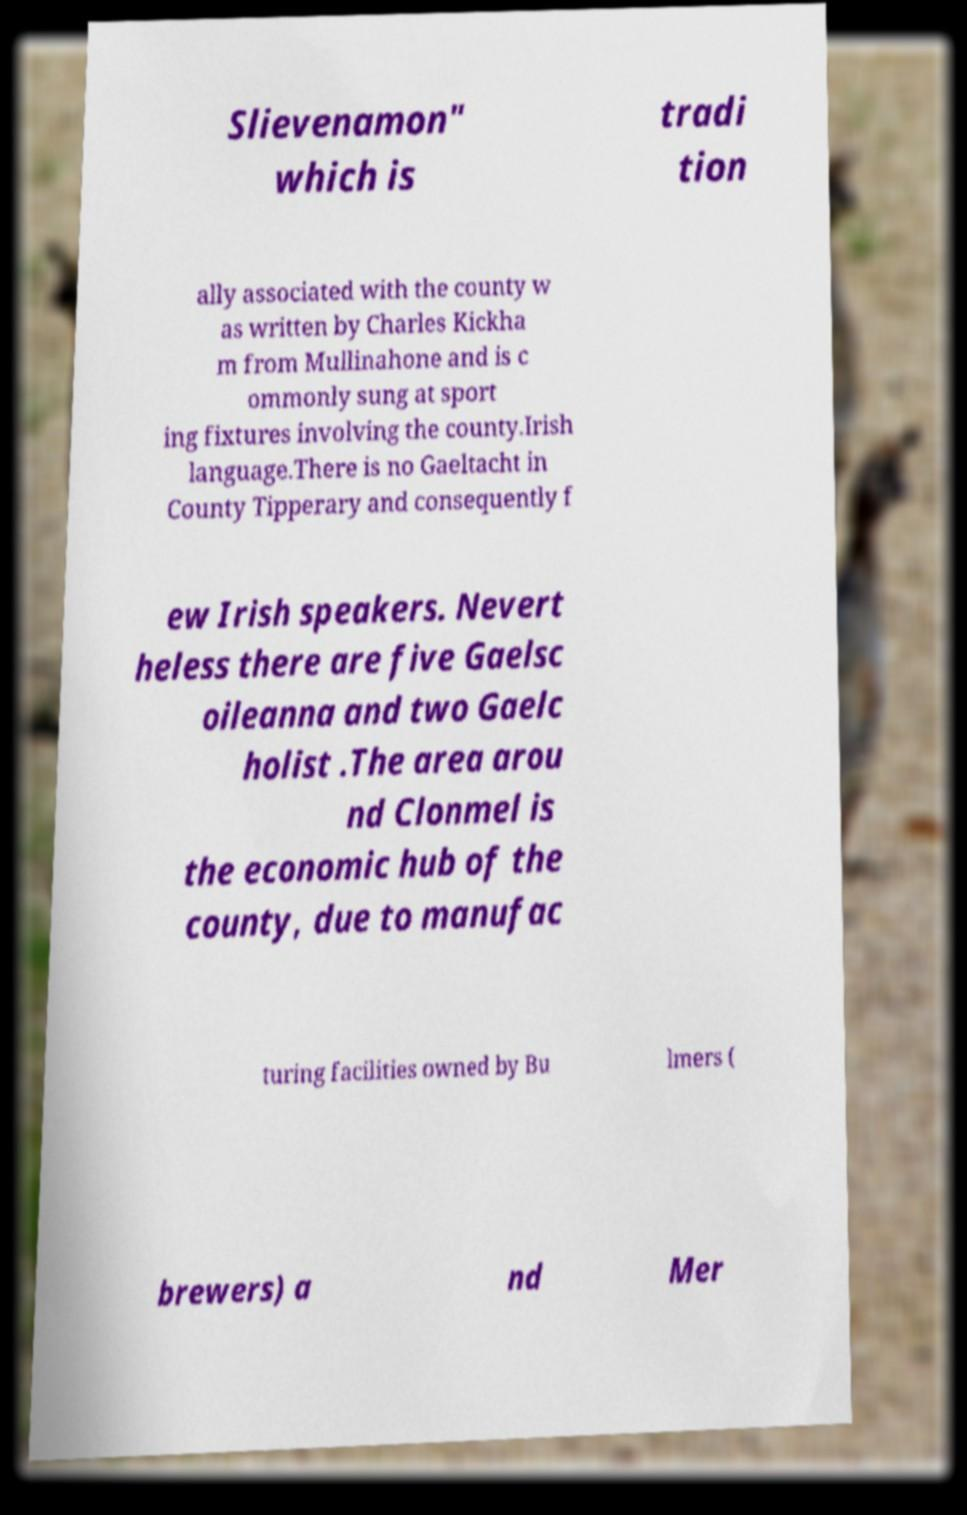Please identify and transcribe the text found in this image. Slievenamon" which is tradi tion ally associated with the county w as written by Charles Kickha m from Mullinahone and is c ommonly sung at sport ing fixtures involving the county.Irish language.There is no Gaeltacht in County Tipperary and consequently f ew Irish speakers. Nevert heless there are five Gaelsc oileanna and two Gaelc holist .The area arou nd Clonmel is the economic hub of the county, due to manufac turing facilities owned by Bu lmers ( brewers) a nd Mer 